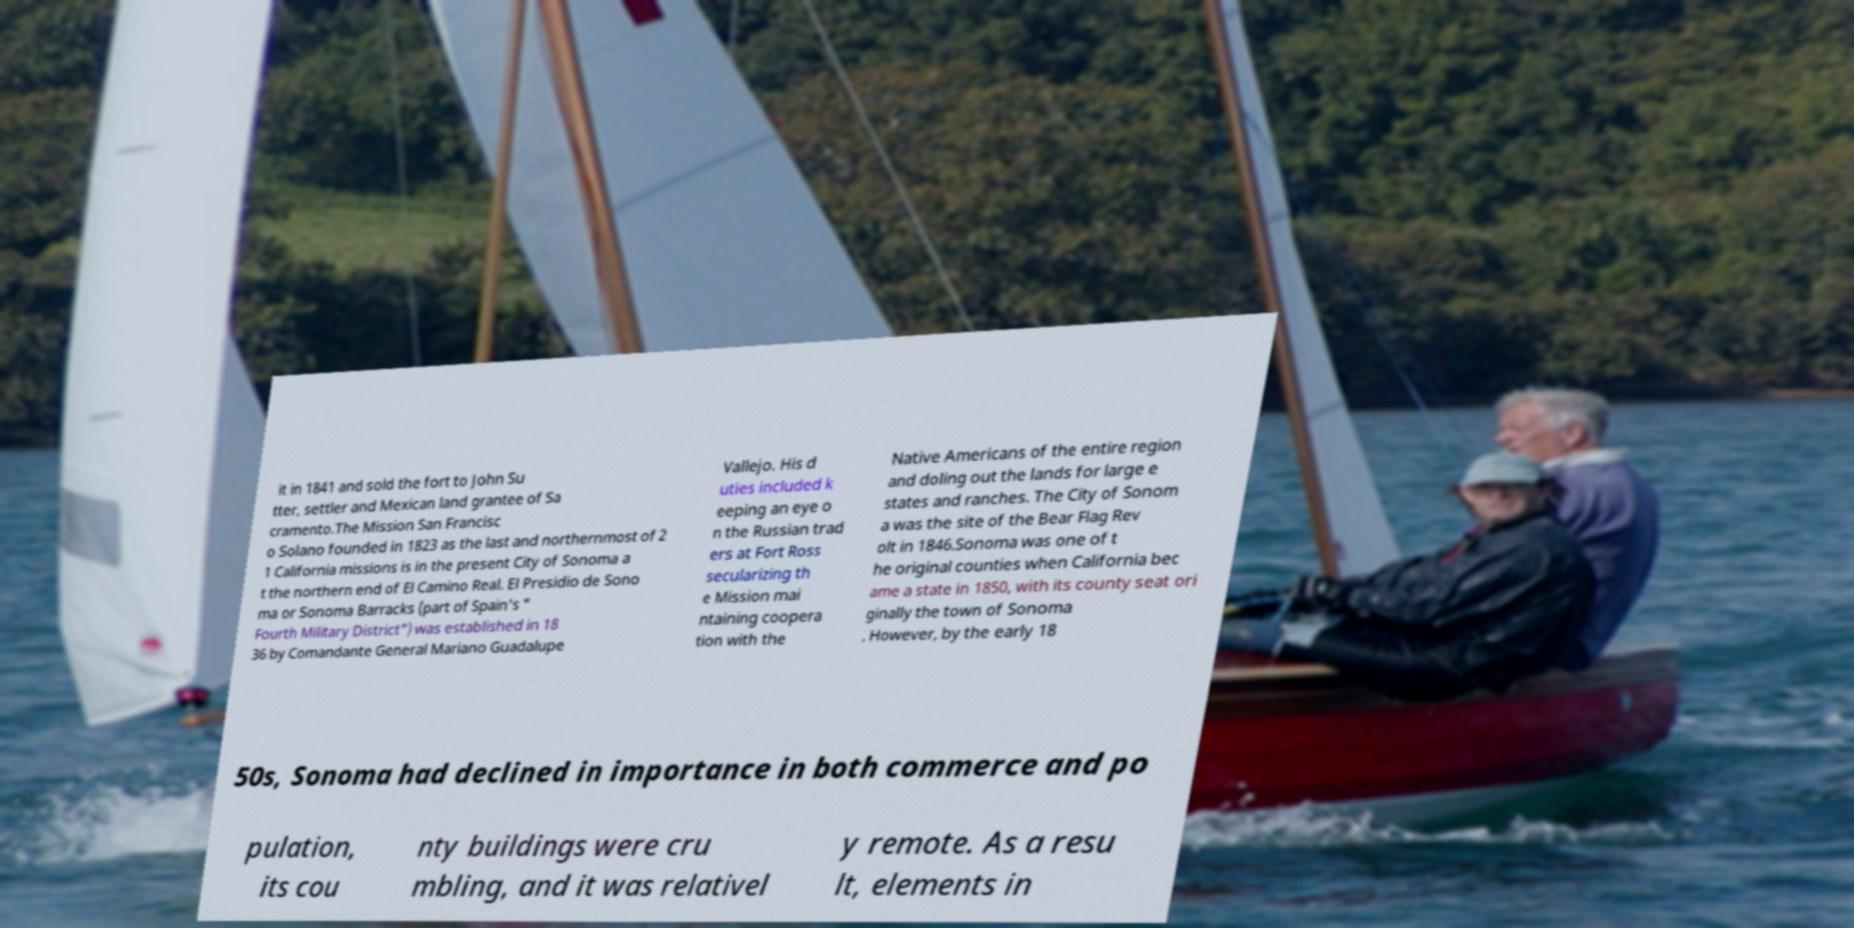There's text embedded in this image that I need extracted. Can you transcribe it verbatim? it in 1841 and sold the fort to John Su tter, settler and Mexican land grantee of Sa cramento.The Mission San Francisc o Solano founded in 1823 as the last and northernmost of 2 1 California missions is in the present City of Sonoma a t the northern end of El Camino Real. El Presidio de Sono ma or Sonoma Barracks (part of Spain's " Fourth Military District") was established in 18 36 by Comandante General Mariano Guadalupe Vallejo. His d uties included k eeping an eye o n the Russian trad ers at Fort Ross secularizing th e Mission mai ntaining coopera tion with the Native Americans of the entire region and doling out the lands for large e states and ranches. The City of Sonom a was the site of the Bear Flag Rev olt in 1846.Sonoma was one of t he original counties when California bec ame a state in 1850, with its county seat ori ginally the town of Sonoma . However, by the early 18 50s, Sonoma had declined in importance in both commerce and po pulation, its cou nty buildings were cru mbling, and it was relativel y remote. As a resu lt, elements in 